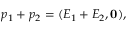<formula> <loc_0><loc_0><loc_500><loc_500>p _ { 1 } + p _ { 2 } = ( E _ { 1 } + E _ { 2 } , 0 ) ,</formula> 